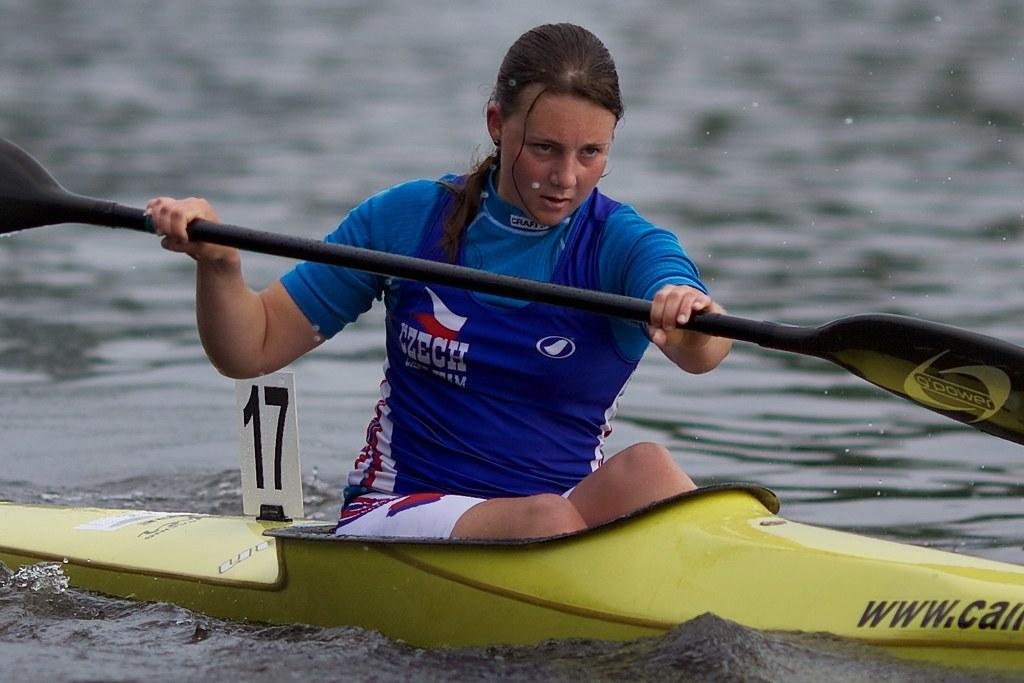Who is present in the image? There is a woman in the image. What is the woman wearing? The woman is wearing a violet jacket. What is the woman doing in the image? The woman is sitting on a seat and holding an oar. What type of vehicle is the woman in? The woman is in a yellow boat. Where is the boat located? The boat is on the water. What type of box is the woman holding in the image? There is no box present in the image; the woman is holding an oar. Can you tell me how many grandmothers are in the image? There is no mention of a grandmother in the image; it features a woman in a yellow boat. 